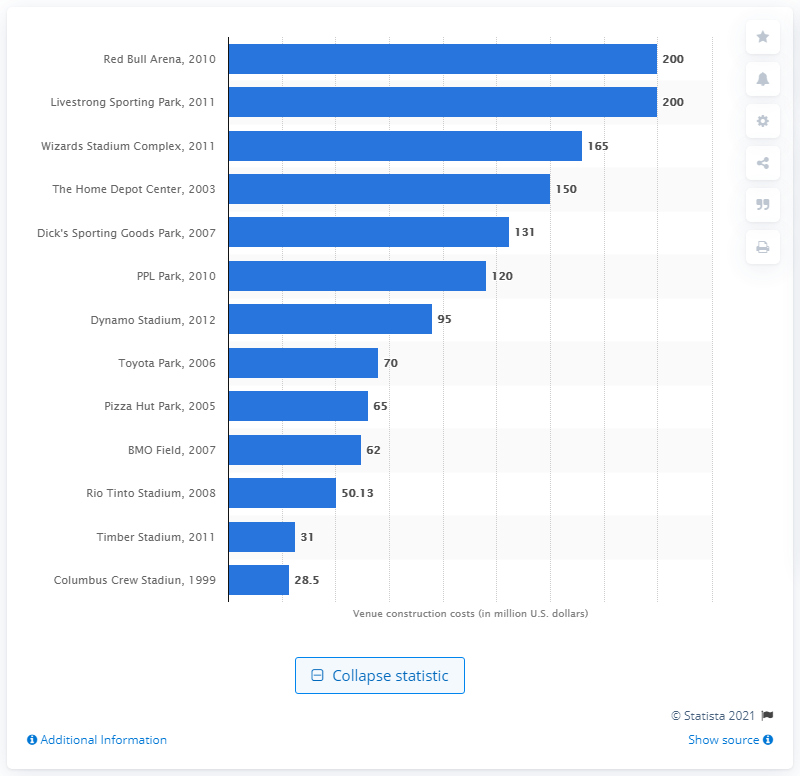Draw attention to some important aspects in this diagram. In 2005, the cost of Pizza Hut Park was $65 million. 